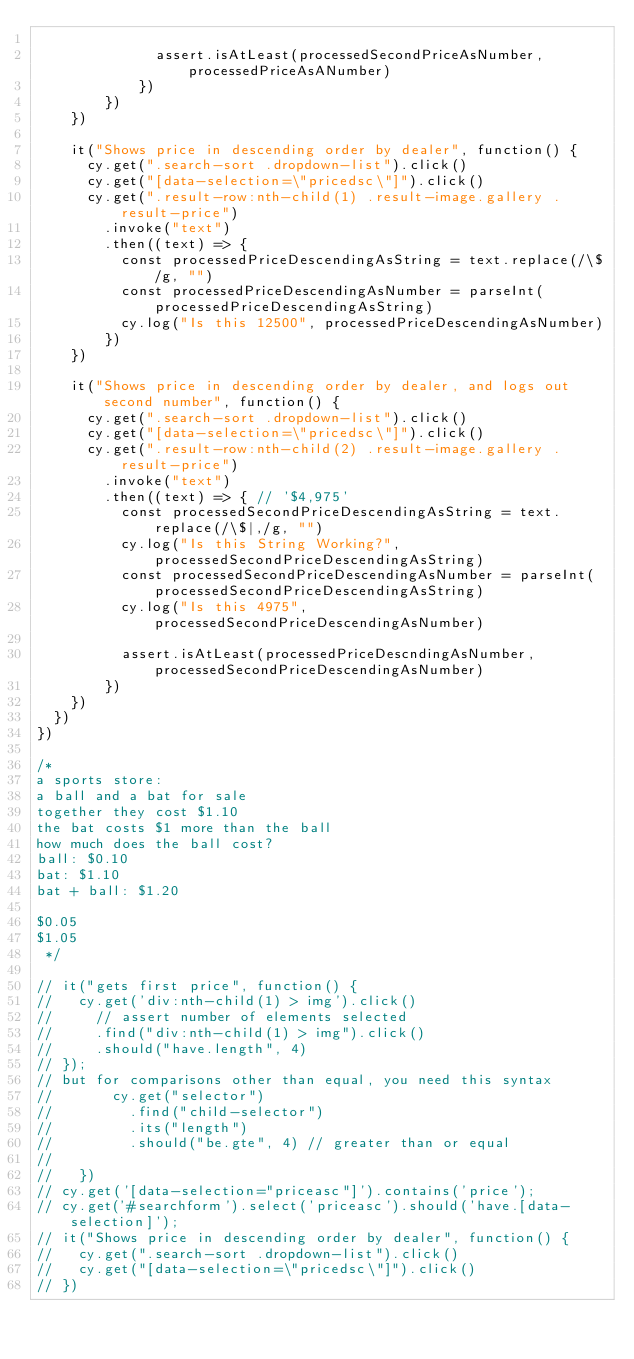<code> <loc_0><loc_0><loc_500><loc_500><_JavaScript_>
              assert.isAtLeast(processedSecondPriceAsNumber, processedPriceAsANumber)
            })
        })
    })

    it("Shows price in descending order by dealer", function() {
      cy.get(".search-sort .dropdown-list").click()
      cy.get("[data-selection=\"pricedsc\"]").click()
      cy.get(".result-row:nth-child(1) .result-image.gallery .result-price")
        .invoke("text")
        .then((text) => {
          const processedPriceDescendingAsString = text.replace(/\$/g, "")
          const processedPriceDescendingAsNumber = parseInt(processedPriceDescendingAsString)
          cy.log("Is this 12500", processedPriceDescendingAsNumber)
        })
    })

    it("Shows price in descending order by dealer, and logs out second number", function() {
      cy.get(".search-sort .dropdown-list").click()
      cy.get("[data-selection=\"pricedsc\"]").click()
      cy.get(".result-row:nth-child(2) .result-image.gallery .result-price")
        .invoke("text")
        .then((text) => { // '$4,975'
          const processedSecondPriceDescendingAsString = text.replace(/\$|,/g, "")
          cy.log("Is this String Working?", processedSecondPriceDescendingAsString)
          const processedSecondPriceDescendingAsNumber = parseInt(processedSecondPriceDescendingAsString)
          cy.log("Is this 4975", processedSecondPriceDescendingAsNumber)

          assert.isAtLeast(processedPriceDescndingAsNumber, processedSecondPriceDescendingAsNumber)
        })
    })
  })
})

/*
a sports store:
a ball and a bat for sale
together they cost $1.10
the bat costs $1 more than the ball
how much does the ball cost?
ball: $0.10
bat: $1.10
bat + ball: $1.20

$0.05
$1.05
 */

// it("gets first price", function() {
//   cy.get('div:nth-child(1) > img').click()
//     // assert number of elements selected
//     .find("div:nth-child(1) > img").click()
//     .should("have.length", 4)
// });
// but for comparisons other than equal, you need this syntax
//       cy.get("selector")
//         .find("child-selector")
//         .its("length")
//         .should("be.gte", 4) // greater than or equal
//
//   })
// cy.get('[data-selection="priceasc"]').contains('price');
// cy.get('#searchform').select('priceasc').should('have.[data-selection]');
// it("Shows price in descending order by dealer", function() {
//   cy.get(".search-sort .dropdown-list").click()
//   cy.get("[data-selection=\"pricedsc\"]").click()
// })

</code> 